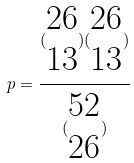Convert formula to latex. <formula><loc_0><loc_0><loc_500><loc_500>p = \frac { ( \begin{matrix} 2 6 \\ 1 3 \end{matrix} ) ( \begin{matrix} 2 6 \\ 1 3 \end{matrix} ) } { ( \begin{matrix} 5 2 \\ 2 6 \end{matrix} ) }</formula> 